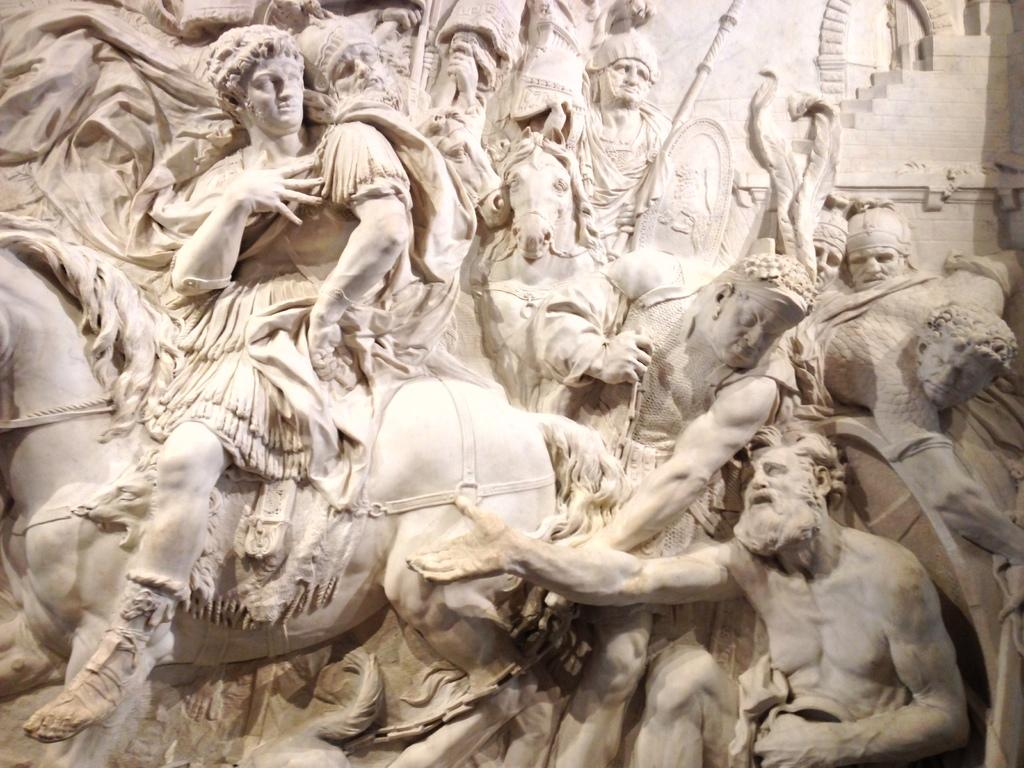What is the main subject of the image? There is a sculpture in the image. Can you describe the appearance of the sculpture? The sculpture is white in color. What is depicted in the sculpture? There is a person sitting on a horse in the sculpture, and there are people holding weapons. Are there any other elements in the sculpture besides the horse and people? Yes, there are other persons in the sculpture. What direction is the father walking in the image? There is no father present in the image, as the main subject is a sculpture. 